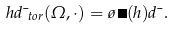Convert formula to latex. <formula><loc_0><loc_0><loc_500><loc_500>h d \mu _ { t o r } ( \Omega , \cdot ) = \tau \, \psi ( h ) d \mu .</formula> 